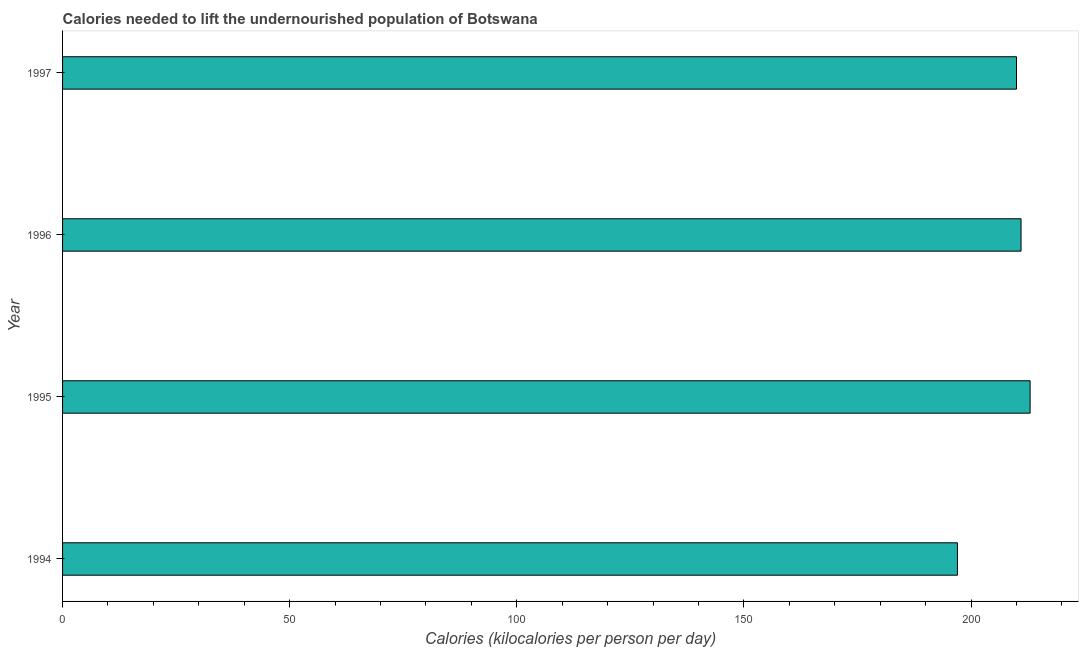What is the title of the graph?
Provide a short and direct response. Calories needed to lift the undernourished population of Botswana. What is the label or title of the X-axis?
Make the answer very short. Calories (kilocalories per person per day). What is the depth of food deficit in 1995?
Provide a short and direct response. 213. Across all years, what is the maximum depth of food deficit?
Make the answer very short. 213. Across all years, what is the minimum depth of food deficit?
Offer a very short reply. 197. In which year was the depth of food deficit maximum?
Keep it short and to the point. 1995. In which year was the depth of food deficit minimum?
Your answer should be compact. 1994. What is the sum of the depth of food deficit?
Offer a terse response. 831. What is the average depth of food deficit per year?
Make the answer very short. 207. What is the median depth of food deficit?
Your answer should be compact. 210.5. What is the ratio of the depth of food deficit in 1994 to that in 1995?
Your answer should be compact. 0.93. Is the depth of food deficit in 1995 less than that in 1997?
Make the answer very short. No. What is the difference between the highest and the second highest depth of food deficit?
Make the answer very short. 2. Are all the bars in the graph horizontal?
Offer a very short reply. Yes. How many years are there in the graph?
Give a very brief answer. 4. Are the values on the major ticks of X-axis written in scientific E-notation?
Give a very brief answer. No. What is the Calories (kilocalories per person per day) of 1994?
Offer a very short reply. 197. What is the Calories (kilocalories per person per day) of 1995?
Your answer should be compact. 213. What is the Calories (kilocalories per person per day) in 1996?
Your answer should be very brief. 211. What is the Calories (kilocalories per person per day) in 1997?
Provide a short and direct response. 210. What is the difference between the Calories (kilocalories per person per day) in 1994 and 1995?
Your answer should be compact. -16. What is the difference between the Calories (kilocalories per person per day) in 1996 and 1997?
Provide a short and direct response. 1. What is the ratio of the Calories (kilocalories per person per day) in 1994 to that in 1995?
Provide a succinct answer. 0.93. What is the ratio of the Calories (kilocalories per person per day) in 1994 to that in 1996?
Your answer should be compact. 0.93. What is the ratio of the Calories (kilocalories per person per day) in 1994 to that in 1997?
Offer a very short reply. 0.94. What is the ratio of the Calories (kilocalories per person per day) in 1995 to that in 1997?
Offer a terse response. 1.01. 